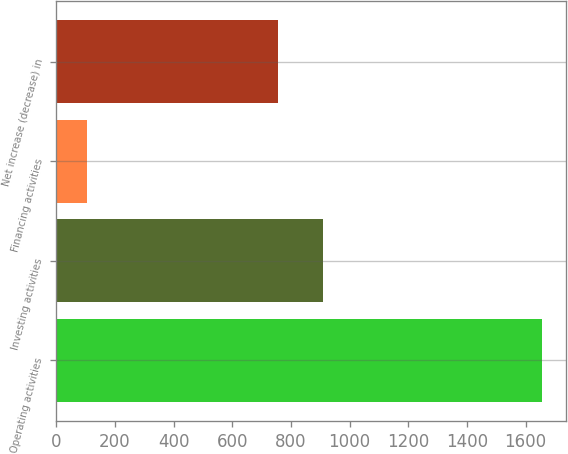Convert chart to OTSL. <chart><loc_0><loc_0><loc_500><loc_500><bar_chart><fcel>Operating activities<fcel>Investing activities<fcel>Financing activities<fcel>Net increase (decrease) in<nl><fcel>1655<fcel>910.9<fcel>106<fcel>756<nl></chart> 